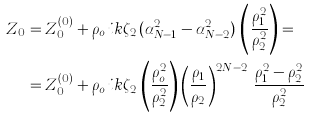<formula> <loc_0><loc_0><loc_500><loc_500>Z _ { 0 } & = Z _ { 0 } ^ { ( 0 ) } + \rho _ { o } \, i k \zeta _ { 2 } \, ( \alpha _ { N - 1 } ^ { 2 } - \alpha _ { N - 2 } ^ { 2 } ) \, \left ( \frac { \rho _ { 1 } ^ { 2 } } { \rho _ { 2 } ^ { 2 } } \right ) = \\ & = Z _ { 0 } ^ { ( 0 ) } + \rho _ { o } \, i k \zeta _ { 2 } \, \left ( \frac { \rho _ { o } ^ { 2 } } { \rho _ { 2 } ^ { 2 } } \right ) \left ( \frac { \rho _ { 1 } } { \rho _ { 2 } } \right ) ^ { 2 N - 2 } \, \frac { \rho _ { 1 } ^ { 2 } - \rho _ { 2 } ^ { 2 } } { \rho _ { 2 } ^ { 2 } }</formula> 